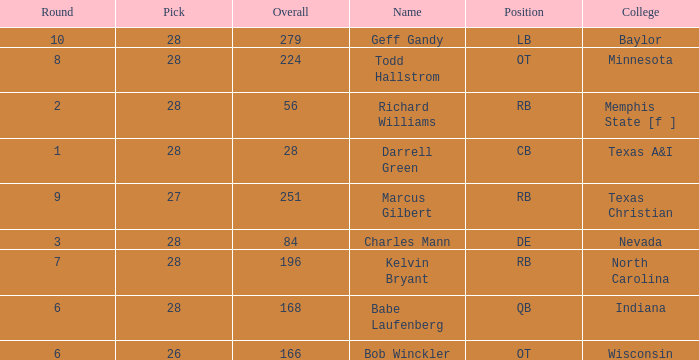What is the lowest round of the position de player with an overall less than 84? None. 